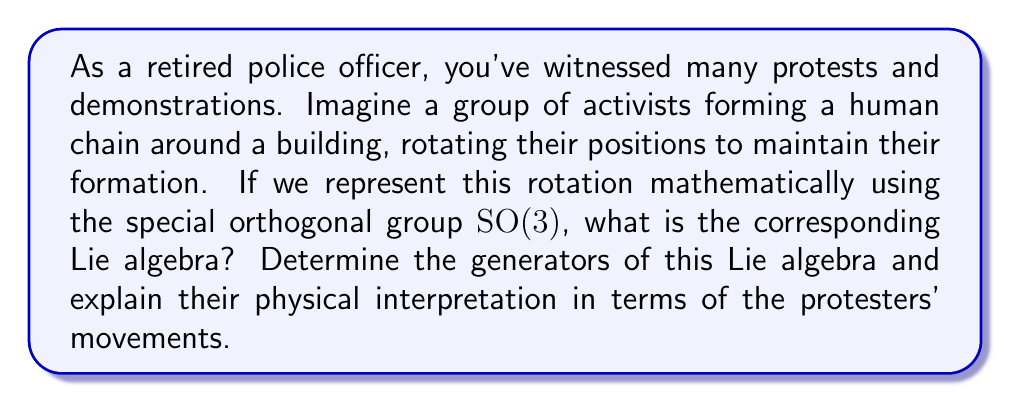Could you help me with this problem? To determine the Lie algebra of SO(3), we follow these steps:

1) First, recall that SO(3) is the group of 3x3 orthogonal matrices with determinant 1. These matrices represent rotations in 3D space.

2) The Lie algebra so(3) consists of the tangent space to SO(3) at the identity. These are infinitesimal rotations.

3) An element $A$ of so(3) must satisfy:

   $$(I + tA)^T(I + tA) = I + O(t^2)$$

   where $I$ is the 3x3 identity matrix and $t$ is a small parameter.

4) Expanding this equation and neglecting terms of order $t^2$ and higher, we get:

   $$I + tA^T + tA = I$$

   This implies $A^T = -A$, meaning $A$ must be skew-symmetric.

5) The general form of a 3x3 skew-symmetric matrix is:

   $$A = \begin{pmatrix}
   0 & -c & b \\
   c & 0 & -a \\
   -b & a & 0
   \end{pmatrix}$$

6) We can express this as a linear combination of three basis matrices:

   $$A = a\begin{pmatrix}
   0 & 0 & 0 \\
   0 & 0 & -1 \\
   0 & 1 & 0
   \end{pmatrix} + b\begin{pmatrix}
   0 & 0 & 1 \\
   0 & 0 & 0 \\
   -1 & 0 & 0
   \end{pmatrix} + c\begin{pmatrix}
   0 & -1 & 0 \\
   1 & 0 & 0 \\
   0 & 0 & 0
   \end{pmatrix}$$

7) These basis matrices are the generators of so(3), often denoted as $L_x$, $L_y$, and $L_z$ respectively.

8) Physically, these generators represent infinitesimal rotations around the x, y, and z axes respectively. In the context of the protesters, they represent the directions in which the human chain can rotate:

   - $L_x$: rotation around the east-west axis
   - $L_y$: rotation around the north-south axis
   - $L_z$: rotation around the vertical axis

9) These generators satisfy the commutation relations:

   $$[L_x, L_y] = L_z, \quad [L_y, L_z] = L_x, \quad [L_z, L_x] = L_y$$

   which define the structure of the Lie algebra so(3).
Answer: The Lie algebra of SO(3) is so(3), which is 3-dimensional and spanned by the generators:

$$L_x = \begin{pmatrix}
0 & 0 & 0 \\
0 & 0 & -1 \\
0 & 1 & 0
\end{pmatrix}, \quad
L_y = \begin{pmatrix}
0 & 0 & 1 \\
0 & 0 & 0 \\
-1 & 0 & 0
\end{pmatrix}, \quad
L_z = \begin{pmatrix}
0 & -1 & 0 \\
1 & 0 & 0 \\
0 & 0 & 0
\end{pmatrix}$$

These generators satisfy the commutation relations $[L_i, L_j] = \epsilon_{ijk}L_k$, where $\epsilon_{ijk}$ is the Levi-Civita symbol. 